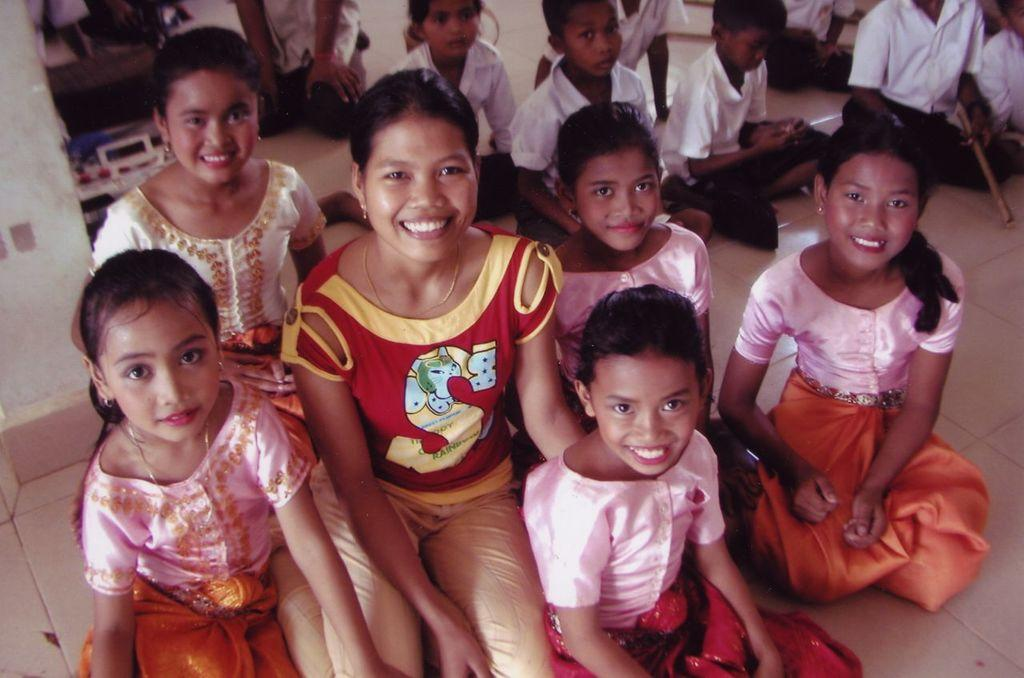Who is present in the image? There are children and a woman in the image. What are the children doing in the image? The children are sitting on the floor. What is the woman doing in the image? The woman is also sitting on the floor. What type of rabbit can be seen playing with the children on the floor in the image? There is no rabbit present in the image; only the children and the woman are visible. Where are the children and the woman on vacation in the image? The image does not provide any information about a vacation or a specific location. 